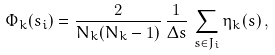<formula> <loc_0><loc_0><loc_500><loc_500>\Phi _ { k } ( s _ { i } ) = \frac { 2 } { N _ { k } ( N _ { k } - 1 ) } \, \frac { 1 } { \Delta s } \, \sum _ { s \in J _ { i } } \eta _ { k } ( s ) \, ,</formula> 